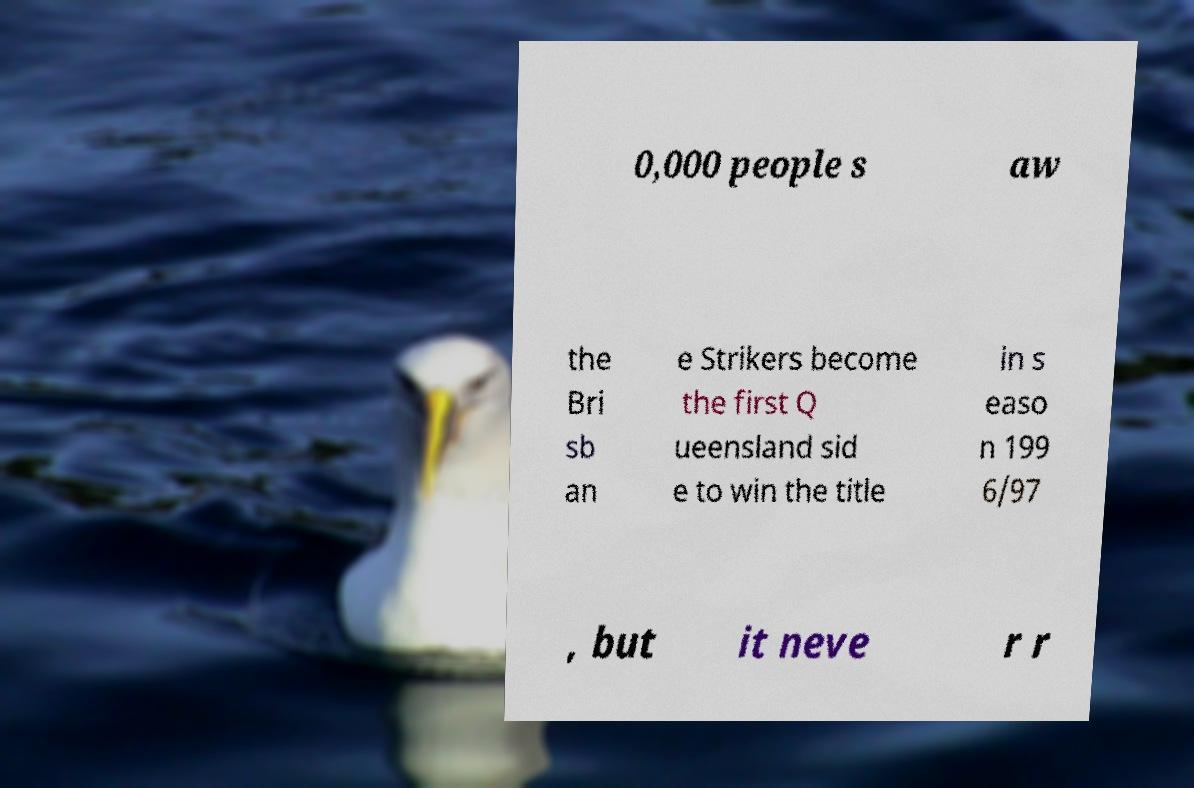What messages or text are displayed in this image? I need them in a readable, typed format. 0,000 people s aw the Bri sb an e Strikers become the first Q ueensland sid e to win the title in s easo n 199 6/97 , but it neve r r 